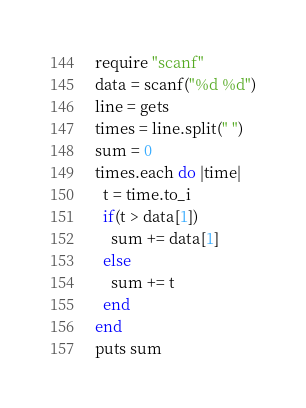Convert code to text. <code><loc_0><loc_0><loc_500><loc_500><_Ruby_>require "scanf"
data = scanf("%d %d")
line = gets
times = line.split(" ")
sum = 0
times.each do |time|
  t = time.to_i
  if(t > data[1])
    sum += data[1]
  else
    sum += t
  end
end
puts sum</code> 